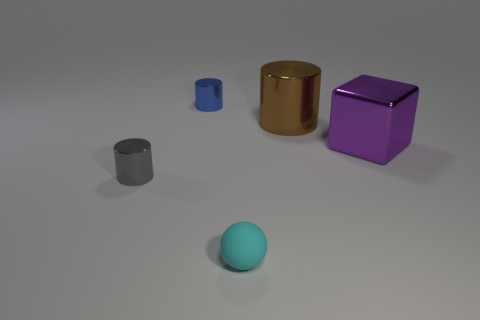What number of other objects are the same size as the ball?
Provide a succinct answer. 2. There is a metallic cylinder on the right side of the tiny thing in front of the small metallic cylinder on the left side of the small blue metal object; what is its color?
Your response must be concise. Brown. What is the shape of the metallic object that is in front of the large cylinder and on the left side of the large brown metal cylinder?
Your answer should be compact. Cylinder. What number of other objects are there of the same shape as the brown object?
Your answer should be compact. 2. There is a shiny object left of the small metallic cylinder that is behind the small metal cylinder that is in front of the purple object; what is its shape?
Offer a terse response. Cylinder. How many things are cubes or large metallic blocks to the right of the large cylinder?
Offer a very short reply. 1. There is a thing that is behind the large brown thing; does it have the same shape as the big object to the left of the purple metallic thing?
Your answer should be compact. Yes. How many things are tiny matte balls or gray metal objects?
Offer a terse response. 2. Is there anything else that is the same material as the small cyan sphere?
Provide a short and direct response. No. Are there any cyan cubes?
Your answer should be compact. No. 